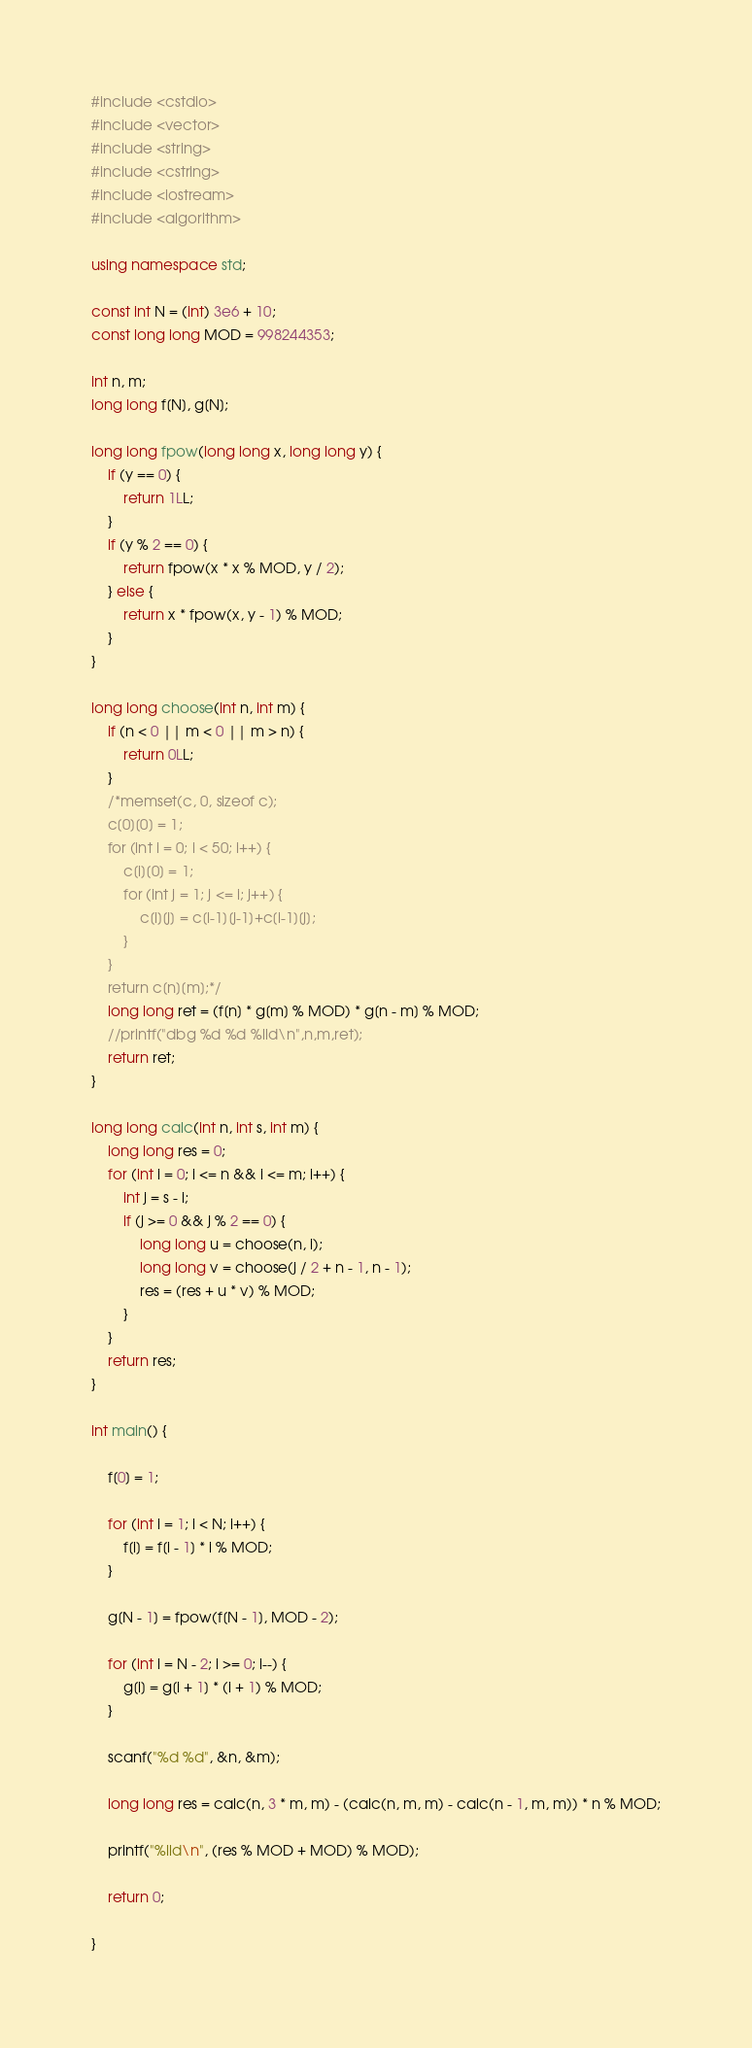<code> <loc_0><loc_0><loc_500><loc_500><_C++_>#include <cstdio>
#include <vector>
#include <string>
#include <cstring>
#include <iostream>
#include <algorithm>

using namespace std;

const int N = (int) 3e6 + 10;
const long long MOD = 998244353;

int n, m;
long long f[N], g[N];

long long fpow(long long x, long long y) {
	if (y == 0) {
		return 1LL;
	}
	if (y % 2 == 0) {
		return fpow(x * x % MOD, y / 2);
	} else {
		return x * fpow(x, y - 1) % MOD;
	}
}

long long choose(int n, int m) {
	if (n < 0 || m < 0 || m > n) {
		return 0LL;
	}
	/*memset(c, 0, sizeof c);
	c[0][0] = 1;
	for (int i = 0; i < 50; i++) {
		c[i][0] = 1;
		for (int j = 1; j <= i; j++) {
			c[i][j] = c[i-1][j-1]+c[i-1][j];
		}
	}
	return c[n][m];*/
	long long ret = (f[n] * g[m] % MOD) * g[n - m] % MOD;
	//printf("dbg %d %d %lld\n",n,m,ret);
	return ret;
}

long long calc(int n, int s, int m) {
	long long res = 0;
	for (int i = 0; i <= n && i <= m; i++) {
		int j = s - i;
		if (j >= 0 && j % 2 == 0) {
			long long u = choose(n, i);
			long long v = choose(j / 2 + n - 1, n - 1);
			res = (res + u * v) % MOD;
		}
	}
	return res;
}

int main() {

	f[0] = 1;

	for (int i = 1; i < N; i++) {
		f[i] = f[i - 1] * i % MOD;
	}

	g[N - 1] = fpow(f[N - 1], MOD - 2);

	for (int i = N - 2; i >= 0; i--) {
		g[i] = g[i + 1] * (i + 1) % MOD;
	}

	scanf("%d %d", &n, &m);

	long long res = calc(n, 3 * m, m) - (calc(n, m, m) - calc(n - 1, m, m)) * n % MOD;

	printf("%lld\n", (res % MOD + MOD) % MOD);

	return 0;

}</code> 